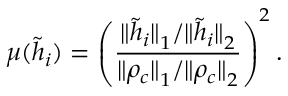<formula> <loc_0><loc_0><loc_500><loc_500>\mu ( \tilde { h } _ { i } ) = \left ( \frac { { \| \tilde { h } _ { i } \| } _ { 1 } / { \| \tilde { h } _ { i } \| } _ { 2 } } { { \| \rho _ { c } \| } _ { 1 } / { \| \rho _ { c } \| } _ { 2 } } \right ) ^ { 2 } .</formula> 